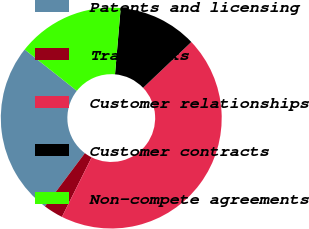<chart> <loc_0><loc_0><loc_500><loc_500><pie_chart><fcel>Patents and licensing<fcel>Trademarks<fcel>Customer relationships<fcel>Customer contracts<fcel>Non-compete agreements<nl><fcel>25.4%<fcel>2.89%<fcel>44.46%<fcel>11.55%<fcel>15.7%<nl></chart> 